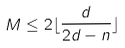Convert formula to latex. <formula><loc_0><loc_0><loc_500><loc_500>M \leq 2 \lfloor \frac { d } { 2 d - n } \rfloor</formula> 